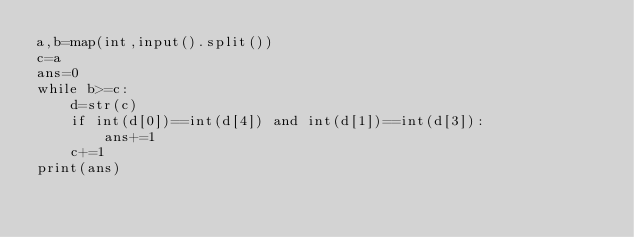<code> <loc_0><loc_0><loc_500><loc_500><_Python_>a,b=map(int,input().split())
c=a
ans=0
while b>=c:
    d=str(c)
    if int(d[0])==int(d[4]) and int(d[1])==int(d[3]):
        ans+=1
    c+=1
print(ans)
</code> 